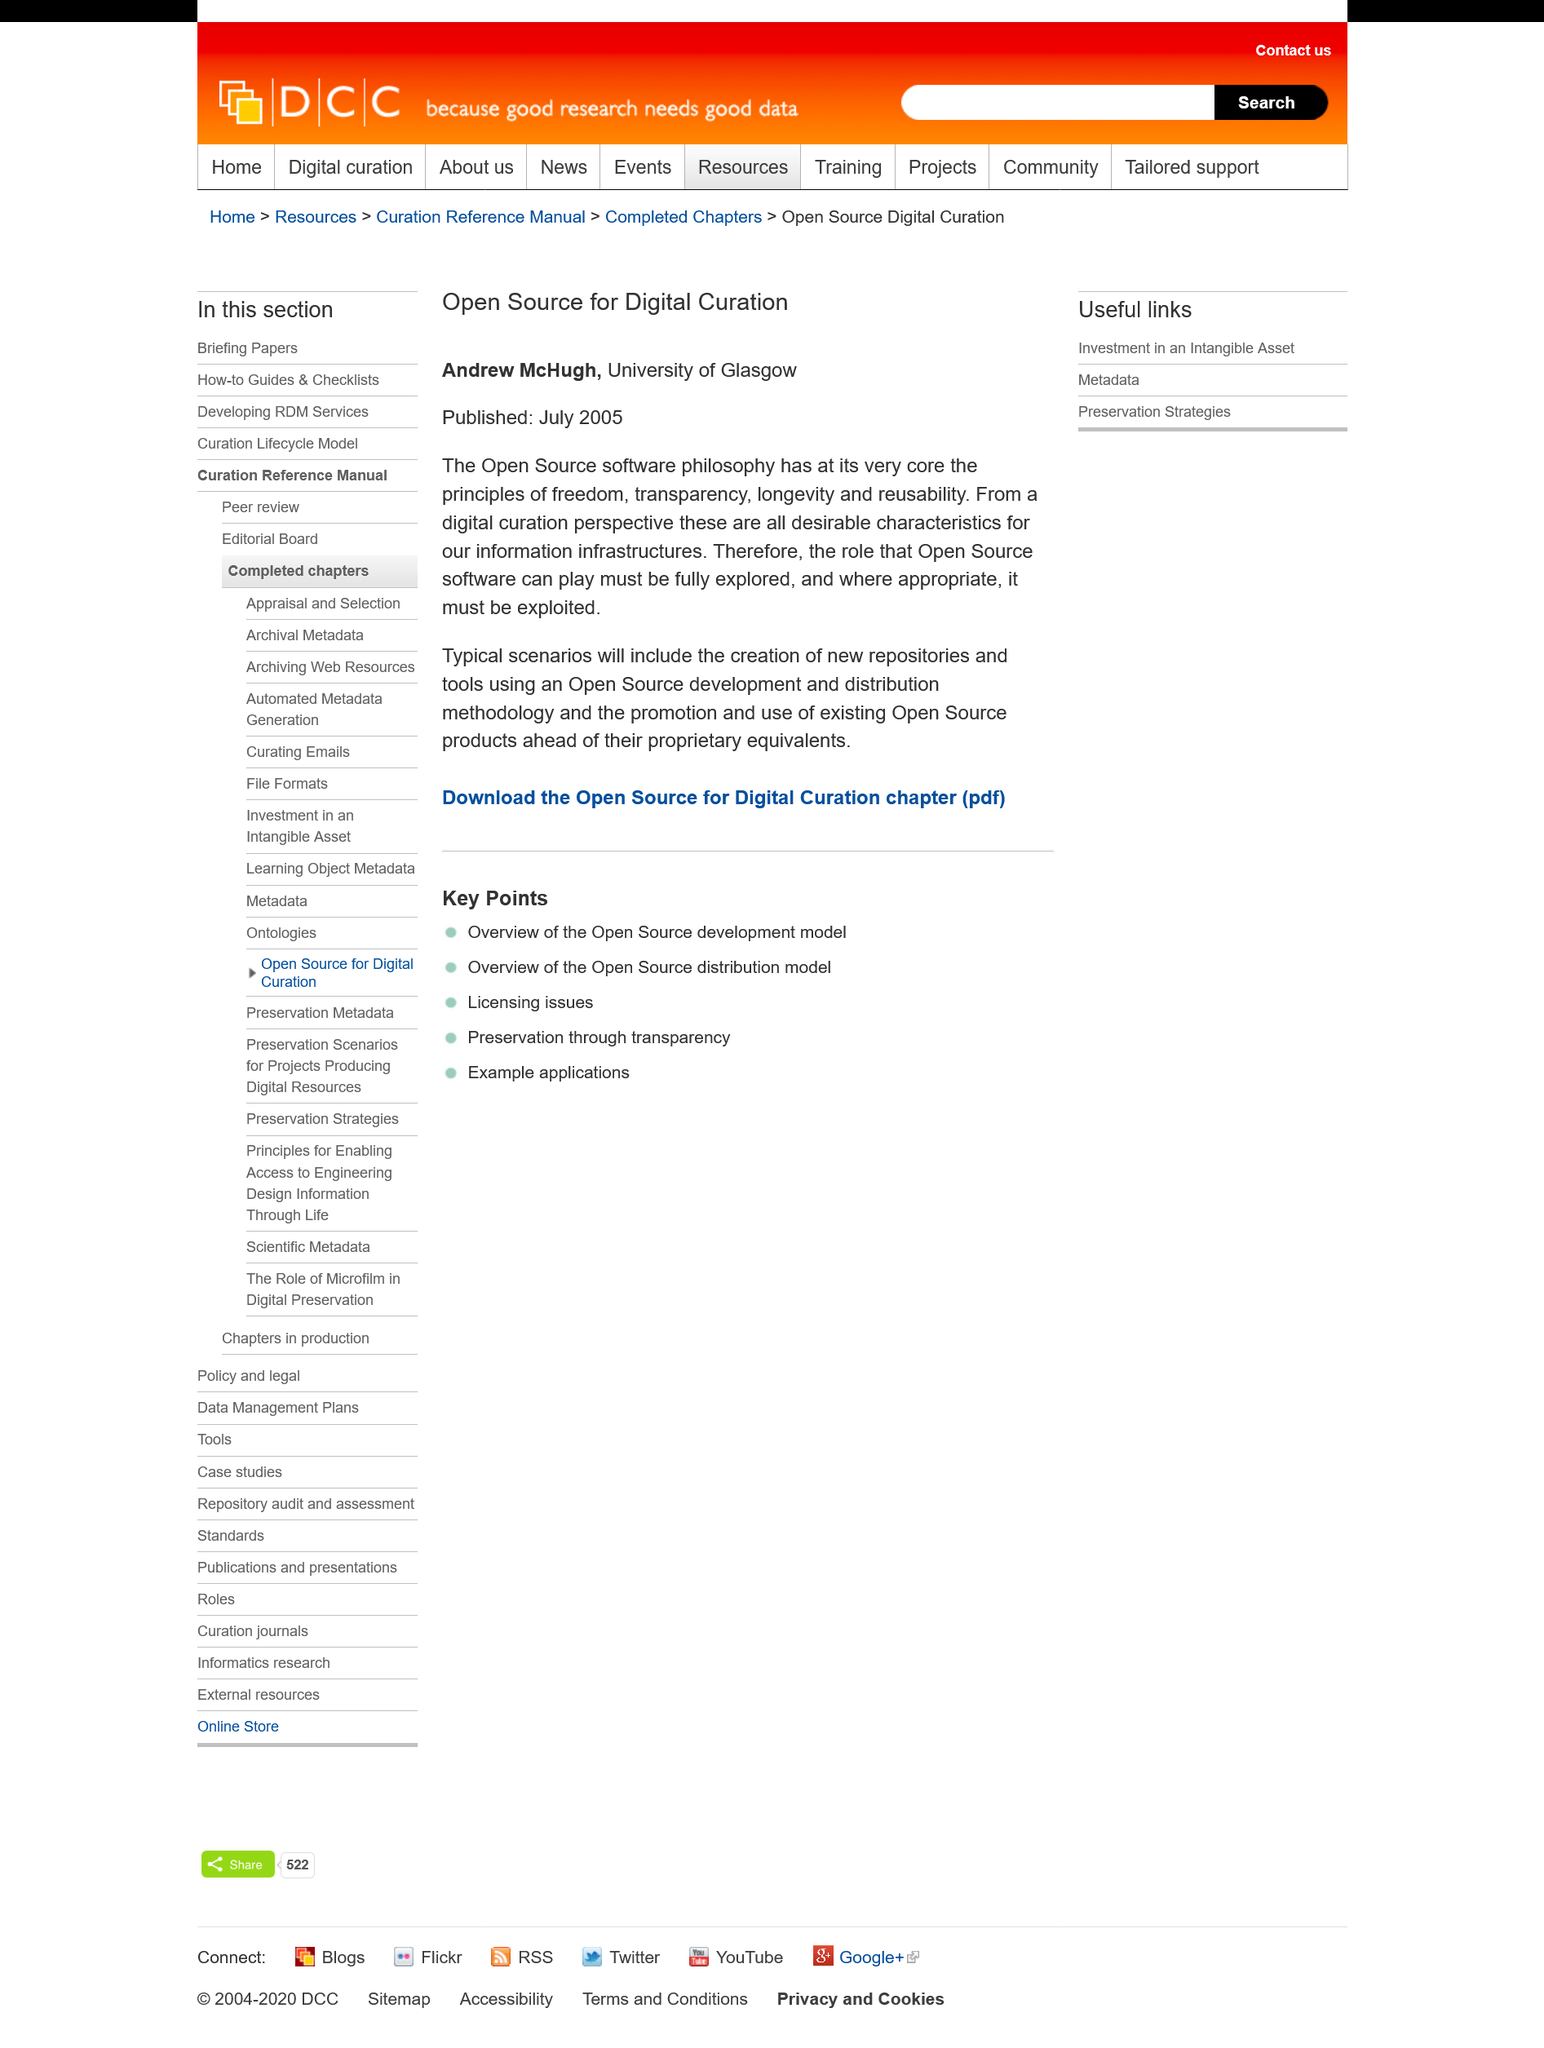List a handful of essential elements in this visual. Andrew McHugh attends the University of Glasgow. This is a title for a topic related to open source solutions for digital curation. This publication was issued in July 2005. 